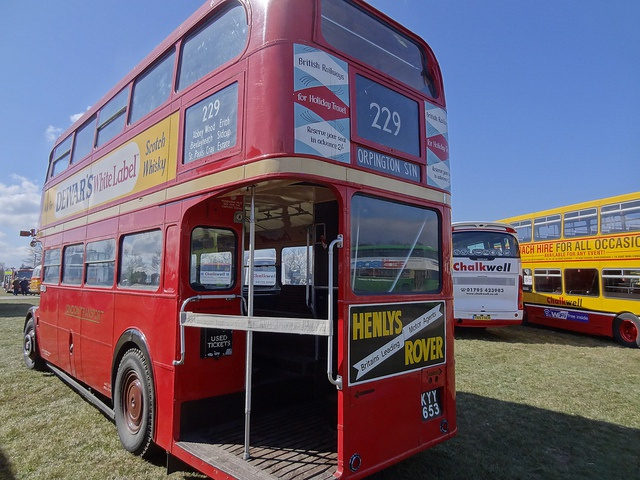Describe the objects in this image and their specific colors. I can see bus in darkgray, black, maroon, and gray tones, bus in darkgray, gold, black, maroon, and gray tones, and bus in darkgray, gray, and navy tones in this image. 